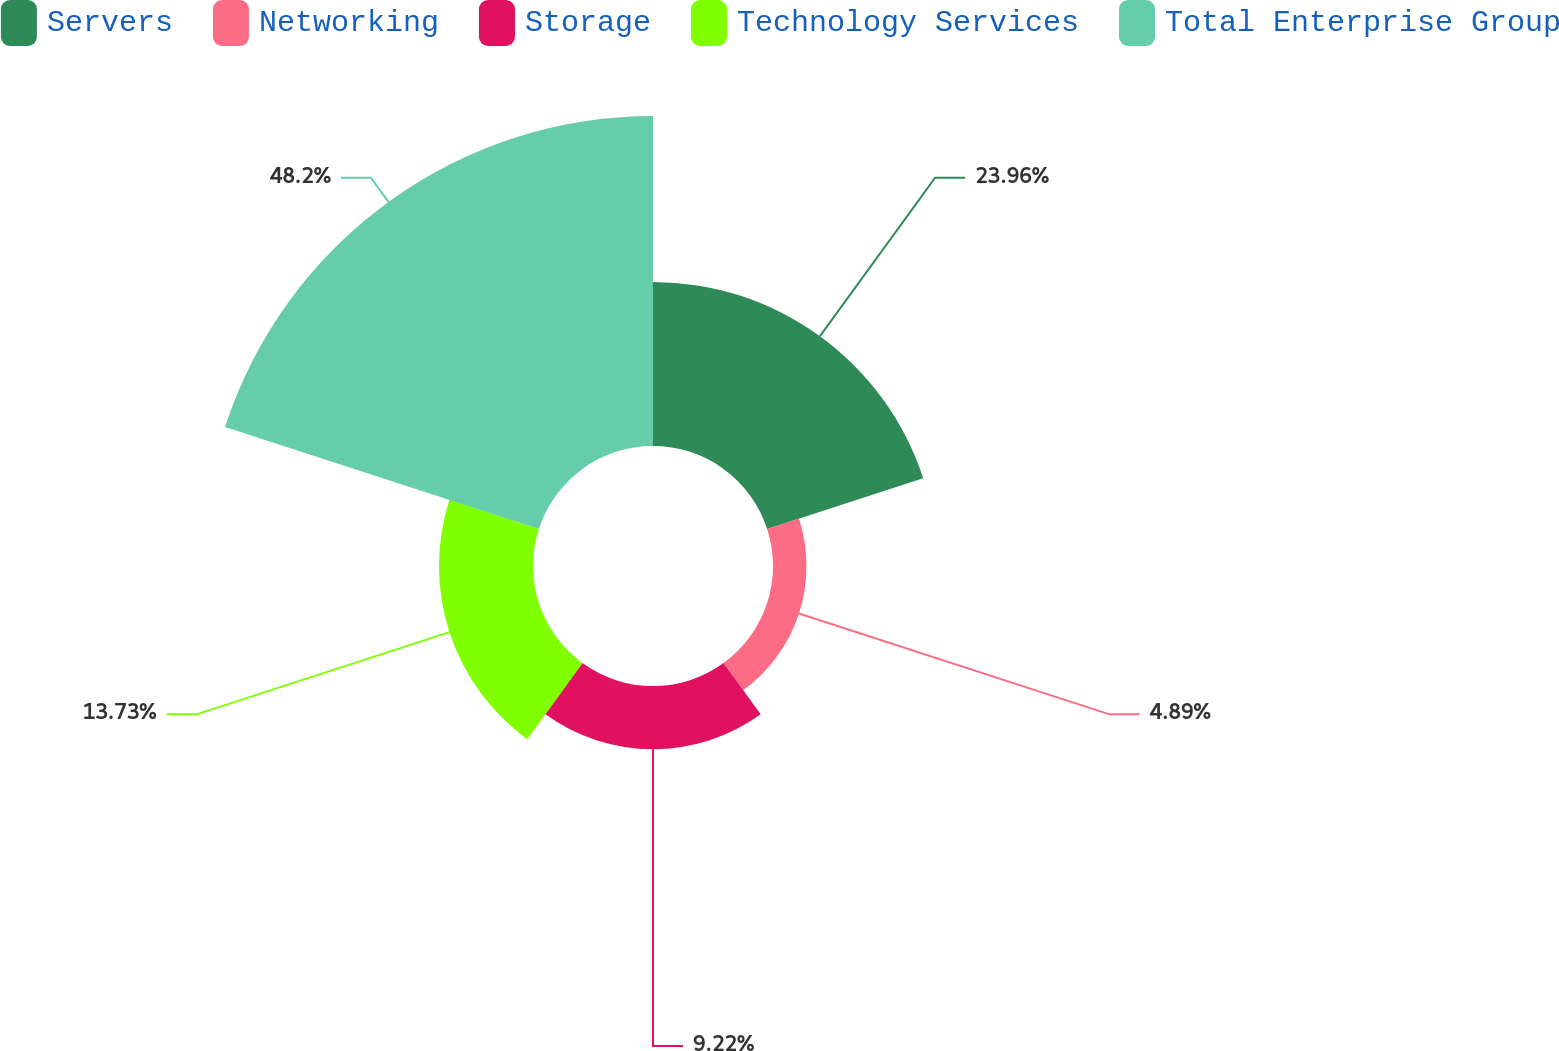<chart> <loc_0><loc_0><loc_500><loc_500><pie_chart><fcel>Servers<fcel>Networking<fcel>Storage<fcel>Technology Services<fcel>Total Enterprise Group<nl><fcel>23.96%<fcel>4.89%<fcel>9.22%<fcel>13.73%<fcel>48.19%<nl></chart> 